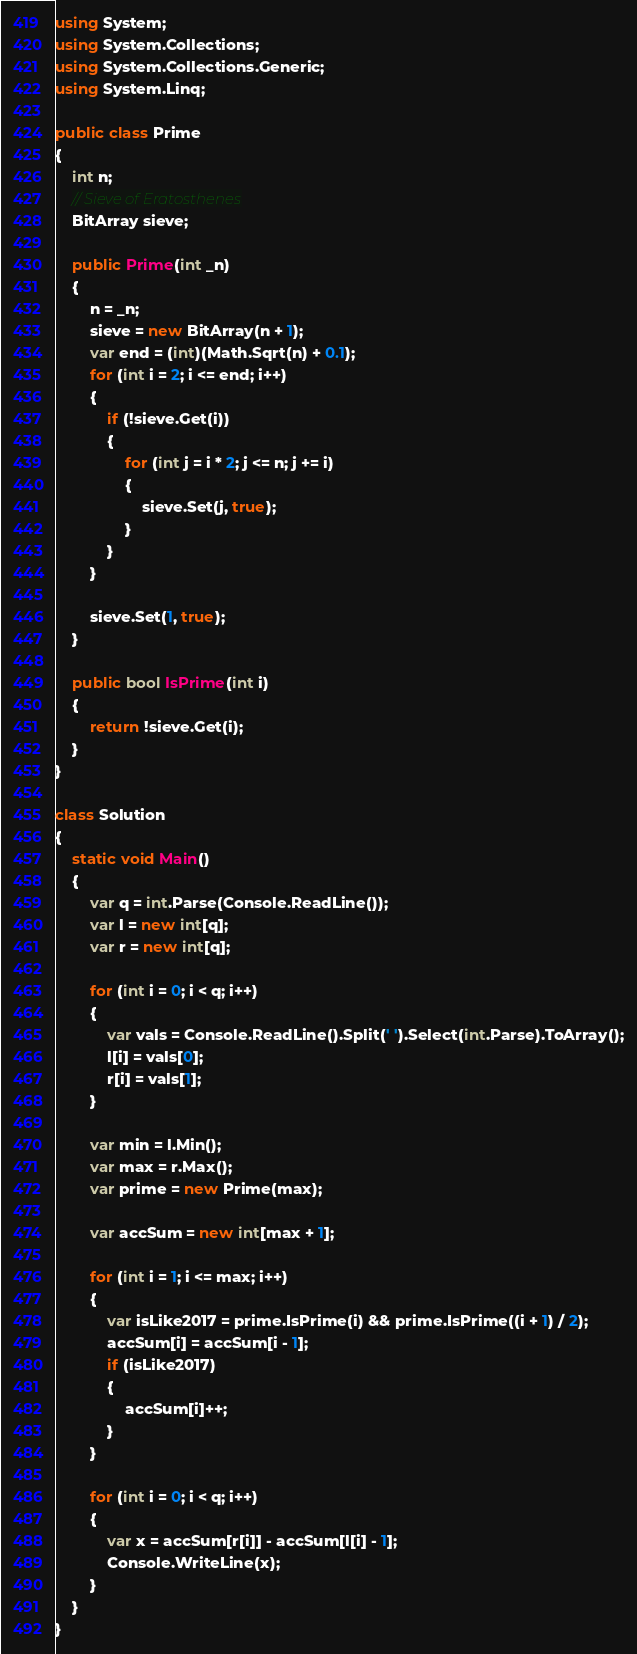<code> <loc_0><loc_0><loc_500><loc_500><_C#_>using System;
using System.Collections;
using System.Collections.Generic;
using System.Linq;

public class Prime
{
    int n;
    // Sieve of Eratosthenes
    BitArray sieve;

    public Prime(int _n)
    {
        n = _n;
        sieve = new BitArray(n + 1);
        var end = (int)(Math.Sqrt(n) + 0.1);
        for (int i = 2; i <= end; i++)
        {
            if (!sieve.Get(i))
            {
                for (int j = i * 2; j <= n; j += i)
                {
                    sieve.Set(j, true);
                }
            }
        }

        sieve.Set(1, true);
    }

    public bool IsPrime(int i)
    {
        return !sieve.Get(i);
    }
}

class Solution
{
    static void Main()
    {
        var q = int.Parse(Console.ReadLine());
        var l = new int[q];
        var r = new int[q];

        for (int i = 0; i < q; i++)
        {
            var vals = Console.ReadLine().Split(' ').Select(int.Parse).ToArray();
            l[i] = vals[0];
            r[i] = vals[1];
        }

        var min = l.Min();
        var max = r.Max();
        var prime = new Prime(max);

        var accSum = new int[max + 1];

        for (int i = 1; i <= max; i++)
        {
            var isLike2017 = prime.IsPrime(i) && prime.IsPrime((i + 1) / 2);
            accSum[i] = accSum[i - 1];
            if (isLike2017)
            {
                accSum[i]++;
            }
        }

        for (int i = 0; i < q; i++)
        {
            var x = accSum[r[i]] - accSum[l[i] - 1];
            Console.WriteLine(x);
        }
    }
}</code> 